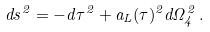<formula> <loc_0><loc_0><loc_500><loc_500>d s ^ { 2 } = - d \tau ^ { 2 } + a _ { L } ( \tau ) ^ { 2 } d \Omega _ { 4 } ^ { 2 } \, .</formula> 